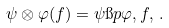<formula> <loc_0><loc_0><loc_500><loc_500>\psi \otimes \varphi ( f ) = \psi \i p \varphi , f , \, .</formula> 